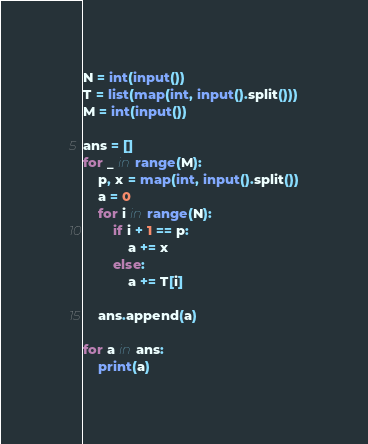Convert code to text. <code><loc_0><loc_0><loc_500><loc_500><_Python_>N = int(input())
T = list(map(int, input().split()))
M = int(input())

ans = []
for _ in range(M):
    p, x = map(int, input().split())
    a = 0
    for i in range(N):
        if i + 1 == p:
            a += x
        else:
            a += T[i]

    ans.append(a)

for a in ans:
    print(a)
</code> 